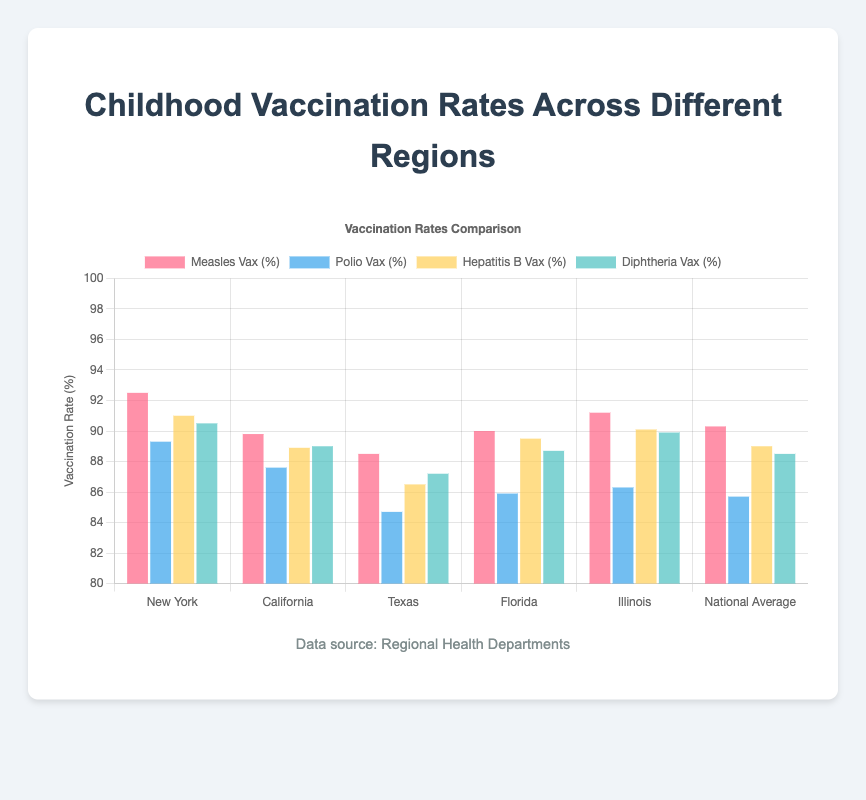Which region has the highest Measles vaccination rate? To determine the region with the highest Measles vaccination rate, compare the bars representing Measles vaccination rates across all regions. New York has the highest bar for Measles vaccination at 92.5%.
Answer: New York Which region has the lowest Polio vaccination rate? Compare the bars representing Polio vaccination rates across all regions. Texas has the lowest Polio vaccination rate at 84.7%.
Answer: Texas How does California's Hepatitis B vaccination rate compare to the National Average? Check the height of the bars for Hepatitis B vaccination for both California and the National Average. California's rate (88.9%) is slightly lower than the National Average (89.0%).
Answer: Slightly lower Is the Diphtheria vaccination rate in Florida above or below the National Average? Compare the Diphtheria vaccination rate bars for Florida and the National Average. Florida's bar (88.7%) is slightly above the National Average (88.5%).
Answer: Above Calculate the average Measles vaccination rate across New York, California, and Texas. Sum the Measles vaccination rates for New York (92.5%), California (89.8%), and Texas (88.5%), then divide by 3: (92.5 + 89.8 + 88.5) / 3 = 90.27%.
Answer: 90.27% What is the difference between Illinois's and Texas's Polio vaccination rates? Subtract the Polio vaccination rate of Texas (84.7%) from Illinois's (86.3%): 86.3 - 84.7 = 1.6%.
Answer: 1.6% Which color represents the highest vaccination rate in New York? Look at the height of the bars for each vaccination type in New York and their colors. The highest bar, representing Measles vaccination, is colored red.
Answer: Red What is the combined vaccination rate of Hepatitis B in Florida and Illinois? Add Florida's Hepatitis B vaccination rate (89.5%) to Illinois's (90.1%): 89.5 + 90.1 = 179.6%.
Answer: 179.6% Does Texas have any vaccination rates above 90%? Review all the bars representing Texas's vaccination rates. None of the bars reach or exceed 90%.
Answer: No By how much does New York's Measles vaccination rate exceed the National Average? Subtract the National Average for Measles vaccination rate (90.3%) from New York's rate (92.5%): 92.5 - 90.3 = 2.2%.
Answer: 2.2% 